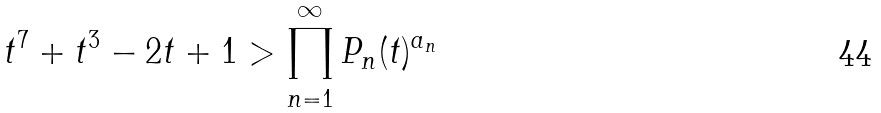<formula> <loc_0><loc_0><loc_500><loc_500>t ^ { 7 } + t ^ { 3 } - 2 t + 1 > \prod _ { n = 1 } ^ { \infty } P _ { n } ( t ) ^ { a _ { n } }</formula> 